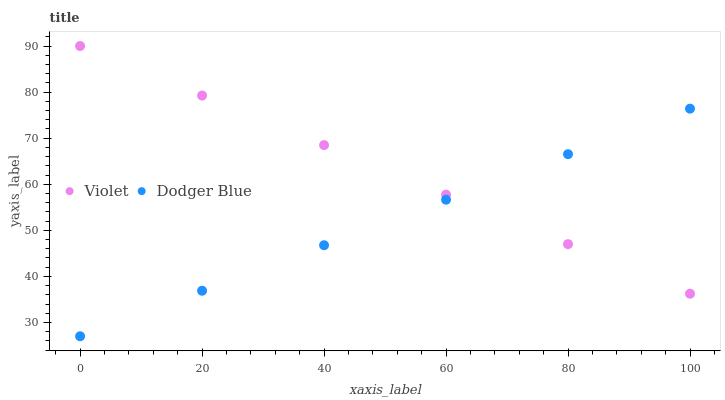Does Dodger Blue have the minimum area under the curve?
Answer yes or no. Yes. Does Violet have the maximum area under the curve?
Answer yes or no. Yes. Does Violet have the minimum area under the curve?
Answer yes or no. No. Is Violet the smoothest?
Answer yes or no. Yes. Is Dodger Blue the roughest?
Answer yes or no. Yes. Is Violet the roughest?
Answer yes or no. No. Does Dodger Blue have the lowest value?
Answer yes or no. Yes. Does Violet have the lowest value?
Answer yes or no. No. Does Violet have the highest value?
Answer yes or no. Yes. Does Dodger Blue intersect Violet?
Answer yes or no. Yes. Is Dodger Blue less than Violet?
Answer yes or no. No. Is Dodger Blue greater than Violet?
Answer yes or no. No. 